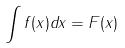Convert formula to latex. <formula><loc_0><loc_0><loc_500><loc_500>\int f ( x ) d x = F ( x )</formula> 